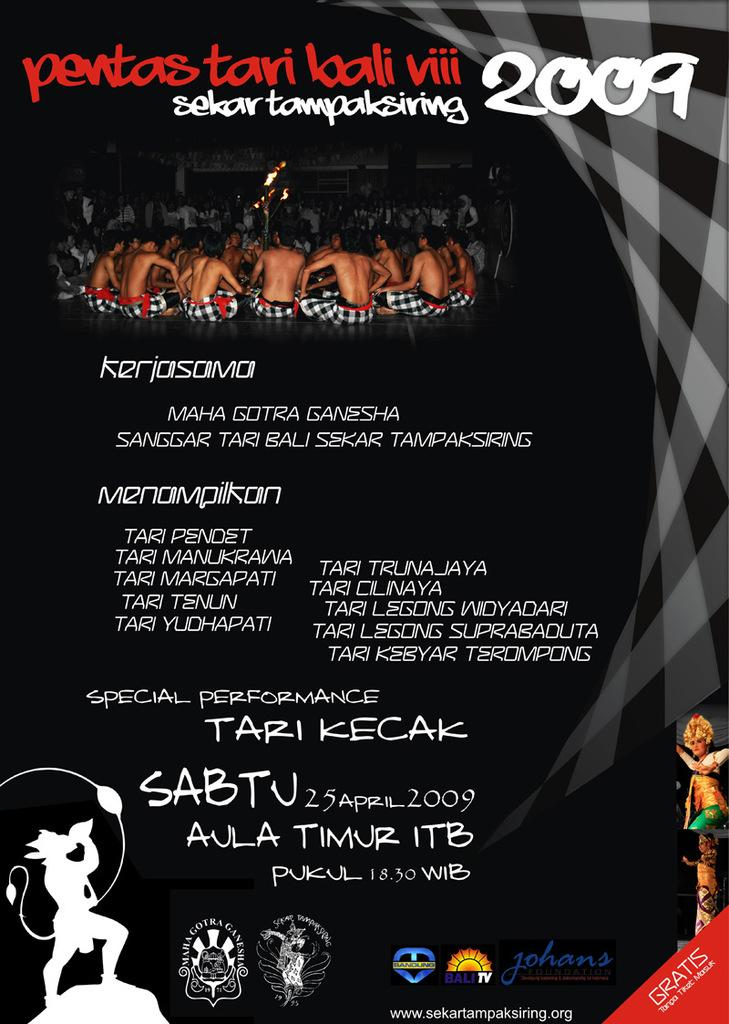<image>
Relay a brief, clear account of the picture shown. A poster for an event with a date of 25 April 2009. 